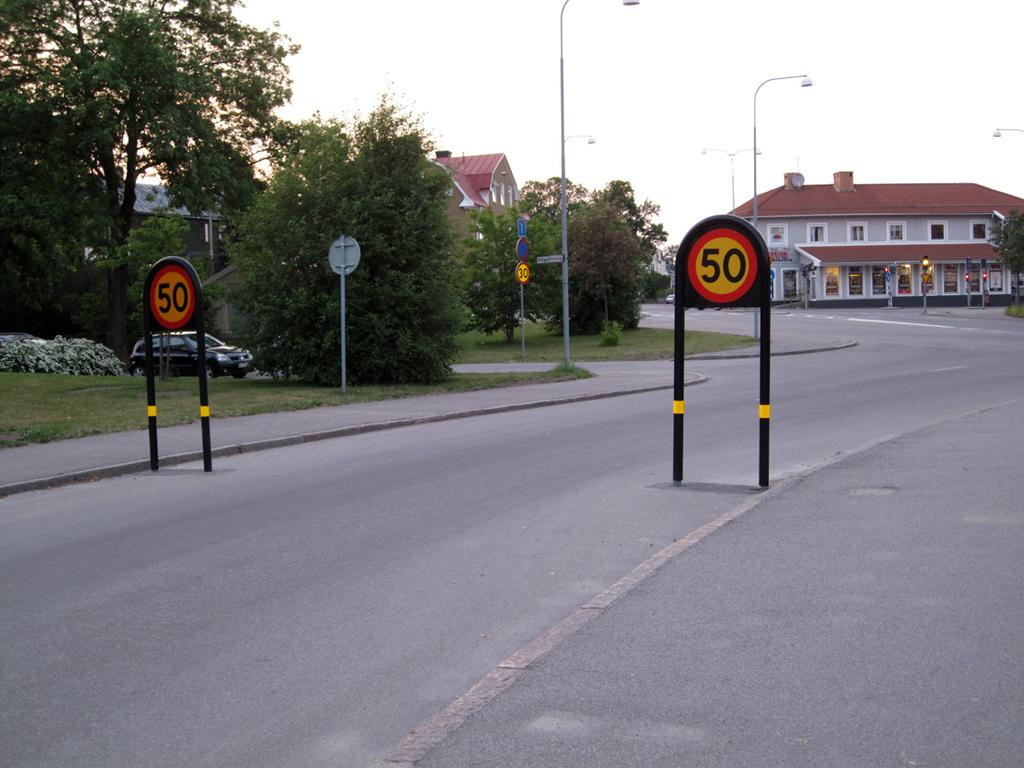<image>
Describe the image concisely. a road sign indicating speed limit is 50 